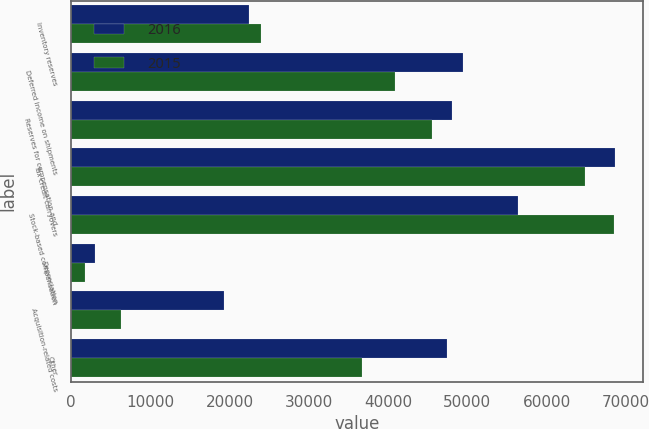<chart> <loc_0><loc_0><loc_500><loc_500><stacked_bar_chart><ecel><fcel>Inventory reserves<fcel>Deferred income on shipments<fcel>Reserves for compensation and<fcel>Tax credit carryovers<fcel>Stock-based compensation<fcel>Depreciation<fcel>Acquisition-related costs<fcel>Other<nl><fcel>2016<fcel>22527<fcel>49455<fcel>48062<fcel>68669<fcel>56345<fcel>3078<fcel>19312<fcel>47482<nl><fcel>2015<fcel>24009<fcel>40842<fcel>45515<fcel>64838<fcel>68530<fcel>1840<fcel>6327<fcel>36711<nl></chart> 